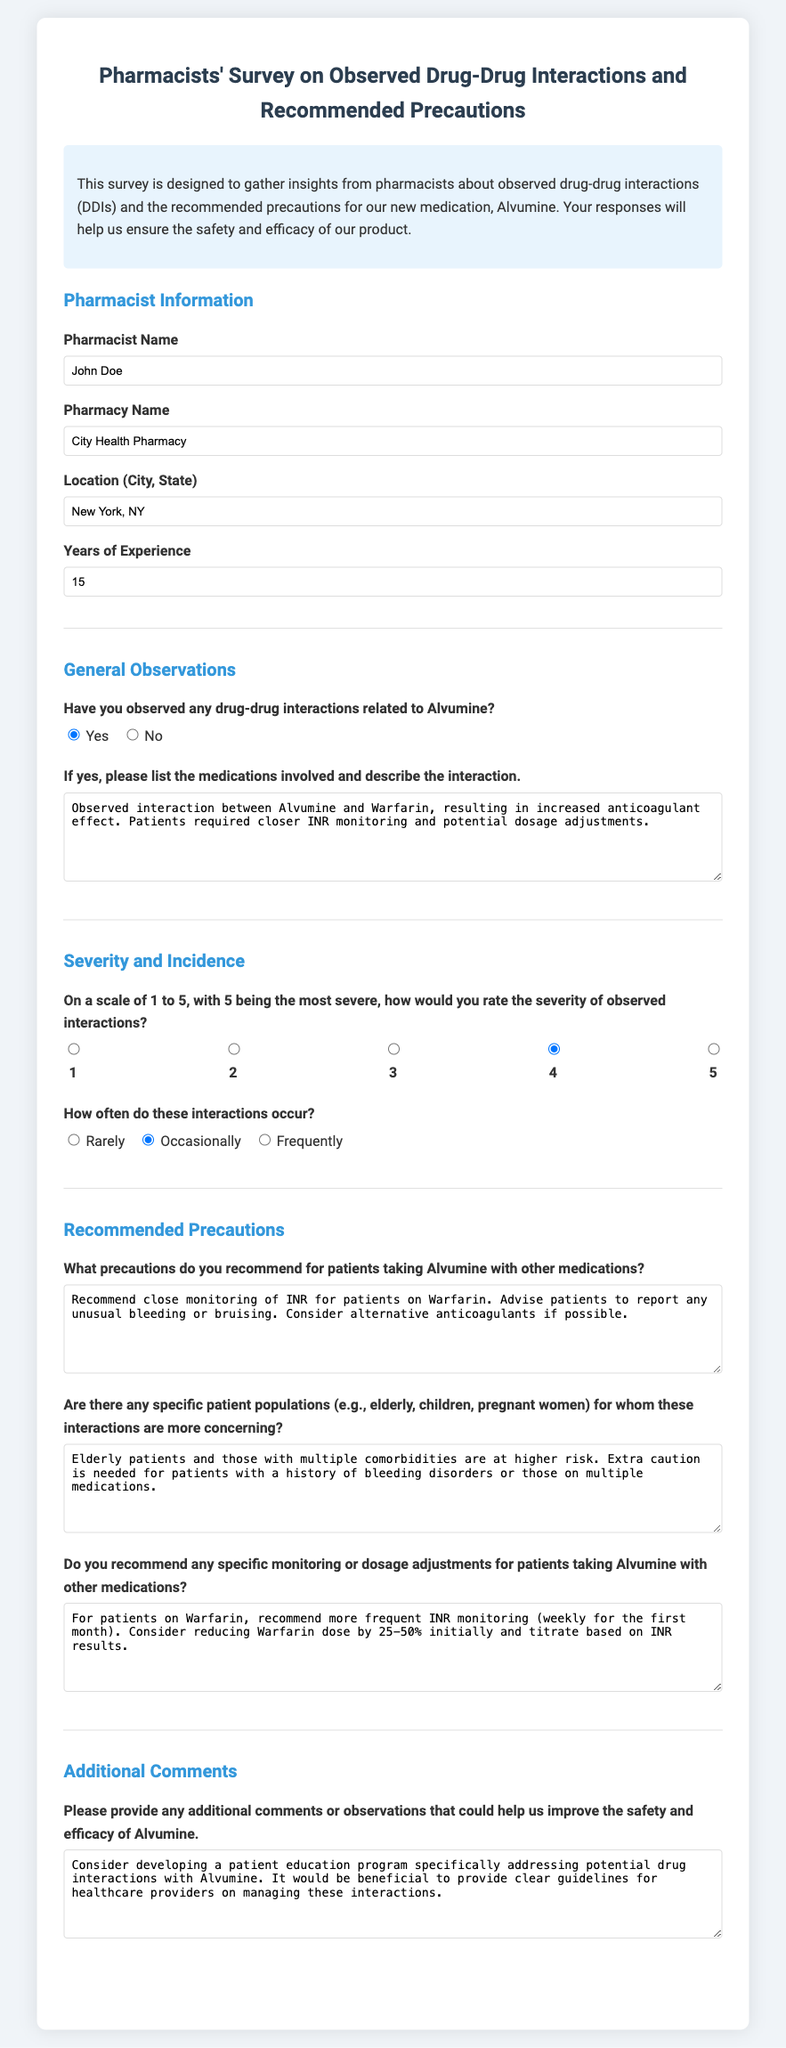What is the pharmacist's name? The pharmacist's name is listed in the survey form under "Pharmacist Name."
Answer: John Doe What is the name of the pharmacy? The name of the pharmacy is provided in the section titled "Pharmacy Name."
Answer: City Health Pharmacy How many years of experience does the pharmacist have? The years of experience is stated in the "Years of Experience" field of the survey.
Answer: 15 What is the severity rating of the observed interactions? The severity rating is given on a scale of 1 to 5 in the "Severity and Incidence" section.
Answer: 4 How often do the interactions occur according to the pharmacist? The frequency of occurrences is specified in the "How often do these interactions occur?" question.
Answer: Occasionally What precautions are recommended for patients taking Alvumine with other medications? The recommended precautions can be found in the "Recommended Precautions" section of the survey.
Answer: Recommend close monitoring of INR for patients on Warfarin Which patient populations are considered more at risk? Specific patient populations that are more concerning are detailed in the "Are there any specific patient populations" question.
Answer: Elderly patients and those with multiple comorbidities What is suggested for monitoring patients on Warfarin? The survey suggests specific monitoring in the "Do you recommend any specific monitoring" section.
Answer: Recommend more frequent INR monitoring (weekly for the first month) What additional comment did the pharmacist provide? Additional comments can be found in the "Additional Comments" section of the survey.
Answer: Consider developing a patient education program specifically addressing potential drug interactions with Alvumine 